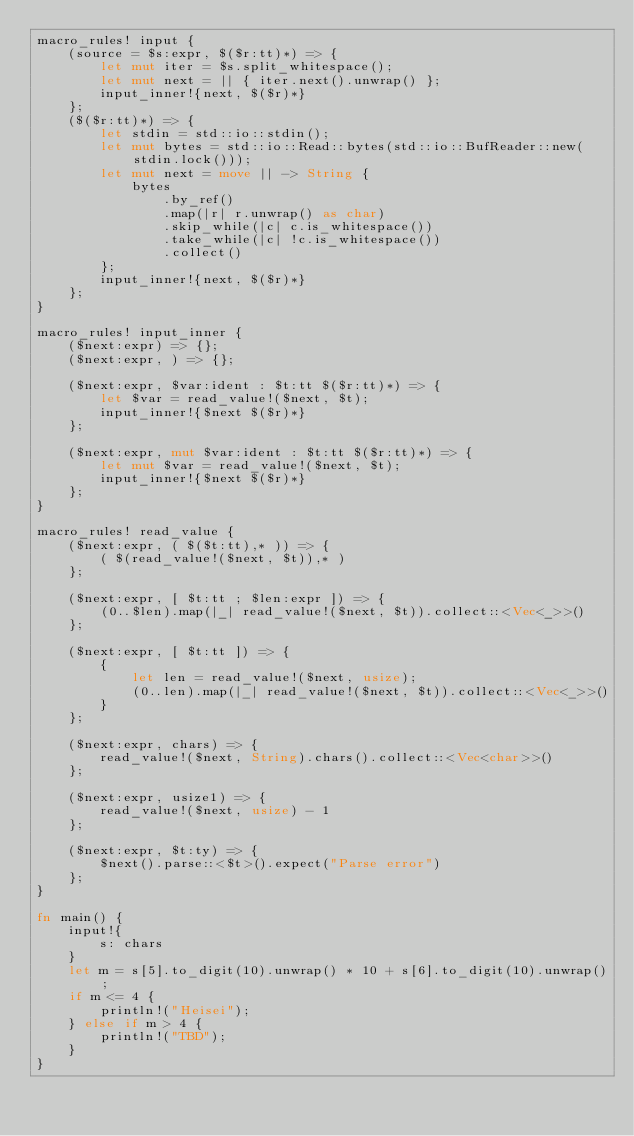Convert code to text. <code><loc_0><loc_0><loc_500><loc_500><_Rust_>macro_rules! input {
    (source = $s:expr, $($r:tt)*) => {
        let mut iter = $s.split_whitespace();
        let mut next = || { iter.next().unwrap() };
        input_inner!{next, $($r)*}
    };
    ($($r:tt)*) => {
        let stdin = std::io::stdin();
        let mut bytes = std::io::Read::bytes(std::io::BufReader::new(stdin.lock()));
        let mut next = move || -> String {
            bytes
                .by_ref()
                .map(|r| r.unwrap() as char)
                .skip_while(|c| c.is_whitespace())
                .take_while(|c| !c.is_whitespace())
                .collect()
        };
        input_inner!{next, $($r)*}
    };
}

macro_rules! input_inner {
    ($next:expr) => {};
    ($next:expr, ) => {};

    ($next:expr, $var:ident : $t:tt $($r:tt)*) => {
        let $var = read_value!($next, $t);
        input_inner!{$next $($r)*}
    };

    ($next:expr, mut $var:ident : $t:tt $($r:tt)*) => {
        let mut $var = read_value!($next, $t);
        input_inner!{$next $($r)*}
    };
}

macro_rules! read_value {
    ($next:expr, ( $($t:tt),* )) => {
        ( $(read_value!($next, $t)),* )
    };

    ($next:expr, [ $t:tt ; $len:expr ]) => {
        (0..$len).map(|_| read_value!($next, $t)).collect::<Vec<_>>()
    };

    ($next:expr, [ $t:tt ]) => {
        {
            let len = read_value!($next, usize);
            (0..len).map(|_| read_value!($next, $t)).collect::<Vec<_>>()
        }
    };

    ($next:expr, chars) => {
        read_value!($next, String).chars().collect::<Vec<char>>()
    };

    ($next:expr, usize1) => {
        read_value!($next, usize) - 1
    };

    ($next:expr, $t:ty) => {
        $next().parse::<$t>().expect("Parse error")
    };
}

fn main() {
    input!{
        s: chars
    }
    let m = s[5].to_digit(10).unwrap() * 10 + s[6].to_digit(10).unwrap();
    if m <= 4 {
        println!("Heisei");
    } else if m > 4 {
        println!("TBD");
    }
}
</code> 